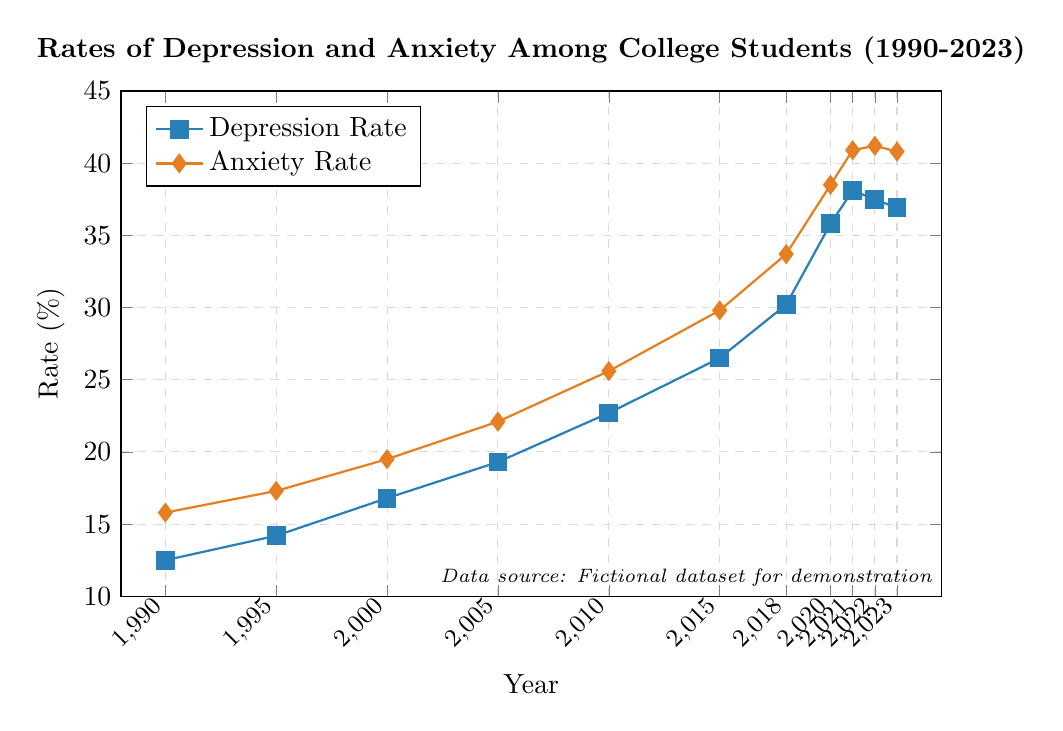How much did the depression rate increase from 1990 to 2023? The depression rate in 1990 was 12.5%, and in 2023 it was 36.9%. Calculating the increase: 36.9 - 12.5 = 24.4%
Answer: 24.4% In which year did the anxiety rate first exceed 30%? Reviewing the data, in 2015 the anxiety rate was 29.8%, and in 2018 it was 33.7%. So, the anxiety rate first exceeded 30% in 2018.
Answer: 2018 During which years did the depression rate show a decrease compared to the previous year? The depression rate decreased from 38.1% in 2021 to 37.5% in 2022, and again from 37.5% in 2022 to 36.9% in 2023. So, the years are 2022 and 2023.
Answer: 2022, 2023 Compare the rates of depression and anxiety in 2000. Which was higher and by how much? In 2000, the depression rate was 16.8% and the anxiety rate was 19.5%. Therefore, the anxiety rate was higher by 19.5 - 16.8 = 2.7%.
Answer: Anxiety rate by 2.7% What is the average depression rate from 1990 to 2005? The depression rates from 1990 to 2005 are: 12.5, 14.2, 16.8, and 19.3. Summing these rates: 12.5 + 14.2 + 16.8 + 19.3 = 62.8. There are 4 data points, so the average is 62.8 / 4 = 15.7%.
Answer: 15.7% What is the total increase in the anxiety rate from 1990 to 2023? The anxiety rate in 1990 was 15.8%, and in 2023 it was 40.8%. Calculating the total increase: 40.8 - 15.8 = 25%.
Answer: 25% By how much did the combined rates of depression and anxiety increase between 2005 and 2020? In 2005, the combined rate was 19.3 (depression) + 22.1 (anxiety) = 41.4%. In 2020, it was 35.8 (depression) + 38.5 (anxiety) = 74.3%. Calculating the increase: 74.3 - 41.4 = 32.9%.
Answer: 32.9% What can be inferred about the trend of depression and anxiety rates over the given period? Both depression and anxiety rates show an overall increasing trend from 1990 to 2023, with some fluctuation near the end. Specifically, the rates of both depression and anxiety saw substantial increases from around 2010 onward.
Answer: Increasing trend Which rate showed a higher percentage increase from 1990 to 2000, depression or anxiety? In 1990, the depression rate was 12.5% and in 2000 it was 16.8%. For anxiety, it was 15.8% in 1990 and 19.5% in 2000. The increases are 16.8 - 12.5 = 4.3% for depression and 19.5 - 15.8 = 3.7% for anxiety. The percentage increases are (4.3 / 12.5) * 100 ≈ 34.4% for depression and (3.7 / 15.8) * 100 ≈ 23.4% for anxiety. Thus, depression showed a higher percentage increase.
Answer: Depression What is the difference in the rates of anxiety between 2018 and 2023? The anxiety rate in 2018 was 33.7%, and in 2023 it was 40.8%. Calculating the difference: 40.8 - 33.7 = 7.1%.
Answer: 7.1% 